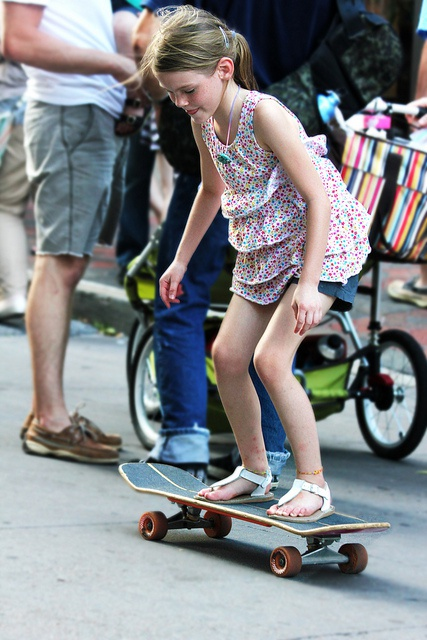Describe the objects in this image and their specific colors. I can see people in white, lightgray, gray, and darkgray tones, people in white, gray, lightgray, darkgray, and lightpink tones, people in white, black, navy, darkblue, and blue tones, bicycle in white, black, darkgray, lightblue, and gray tones, and skateboard in white, black, gray, darkgray, and maroon tones in this image. 